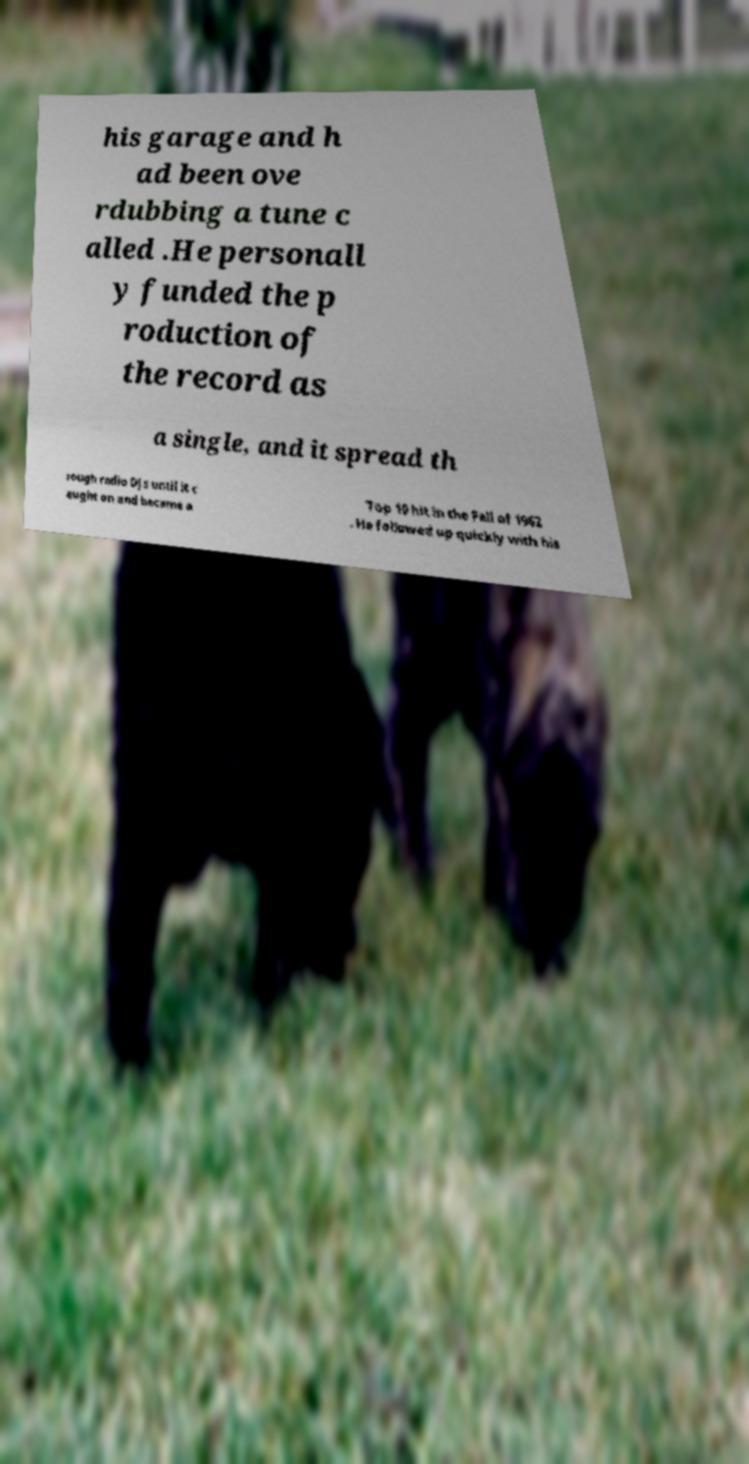For documentation purposes, I need the text within this image transcribed. Could you provide that? his garage and h ad been ove rdubbing a tune c alled .He personall y funded the p roduction of the record as a single, and it spread th rough radio DJs until it c aught on and became a Top 10 hit in the Fall of 1962 . He followed up quickly with his 